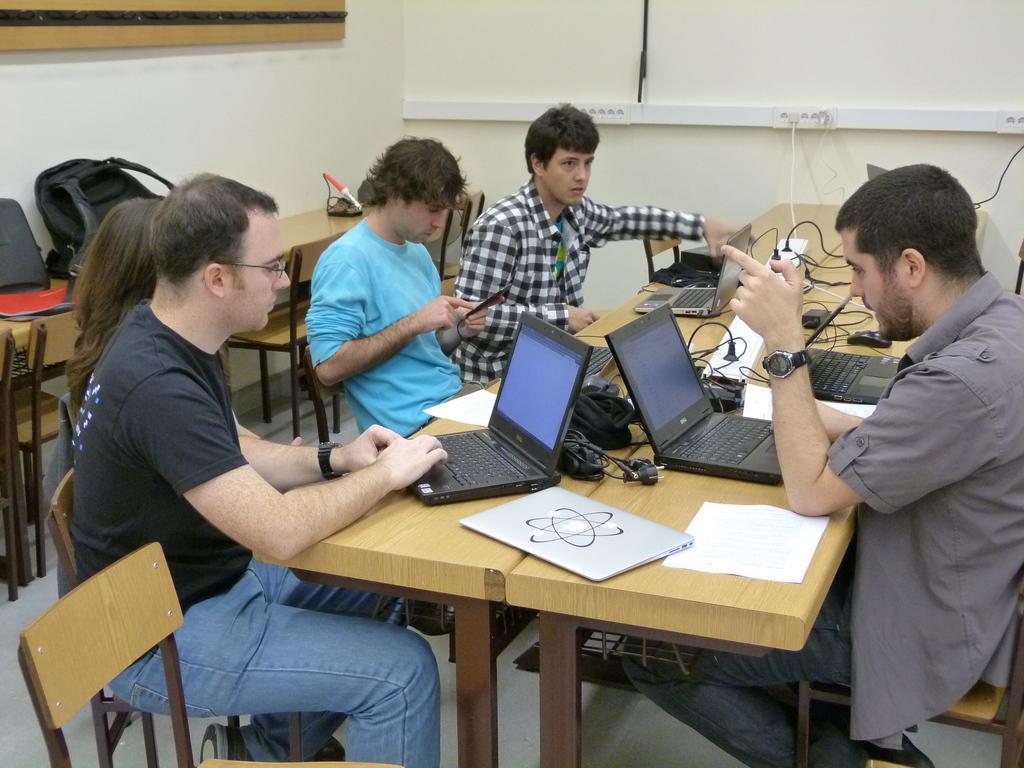In one or two sentences, can you explain what this image depicts? In this picture in the front there is an empty chair. In the center there are persons sitting on the chair, there is a table, on the table there are laptops, papers, wires. In the background there are empty chairs and there is a table, on the table there are bags and on the wall there is an object which is white in colour and on the left side wall there is an object which is brown in colour and black in colour. 